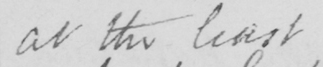What is written in this line of handwriting? at the least 